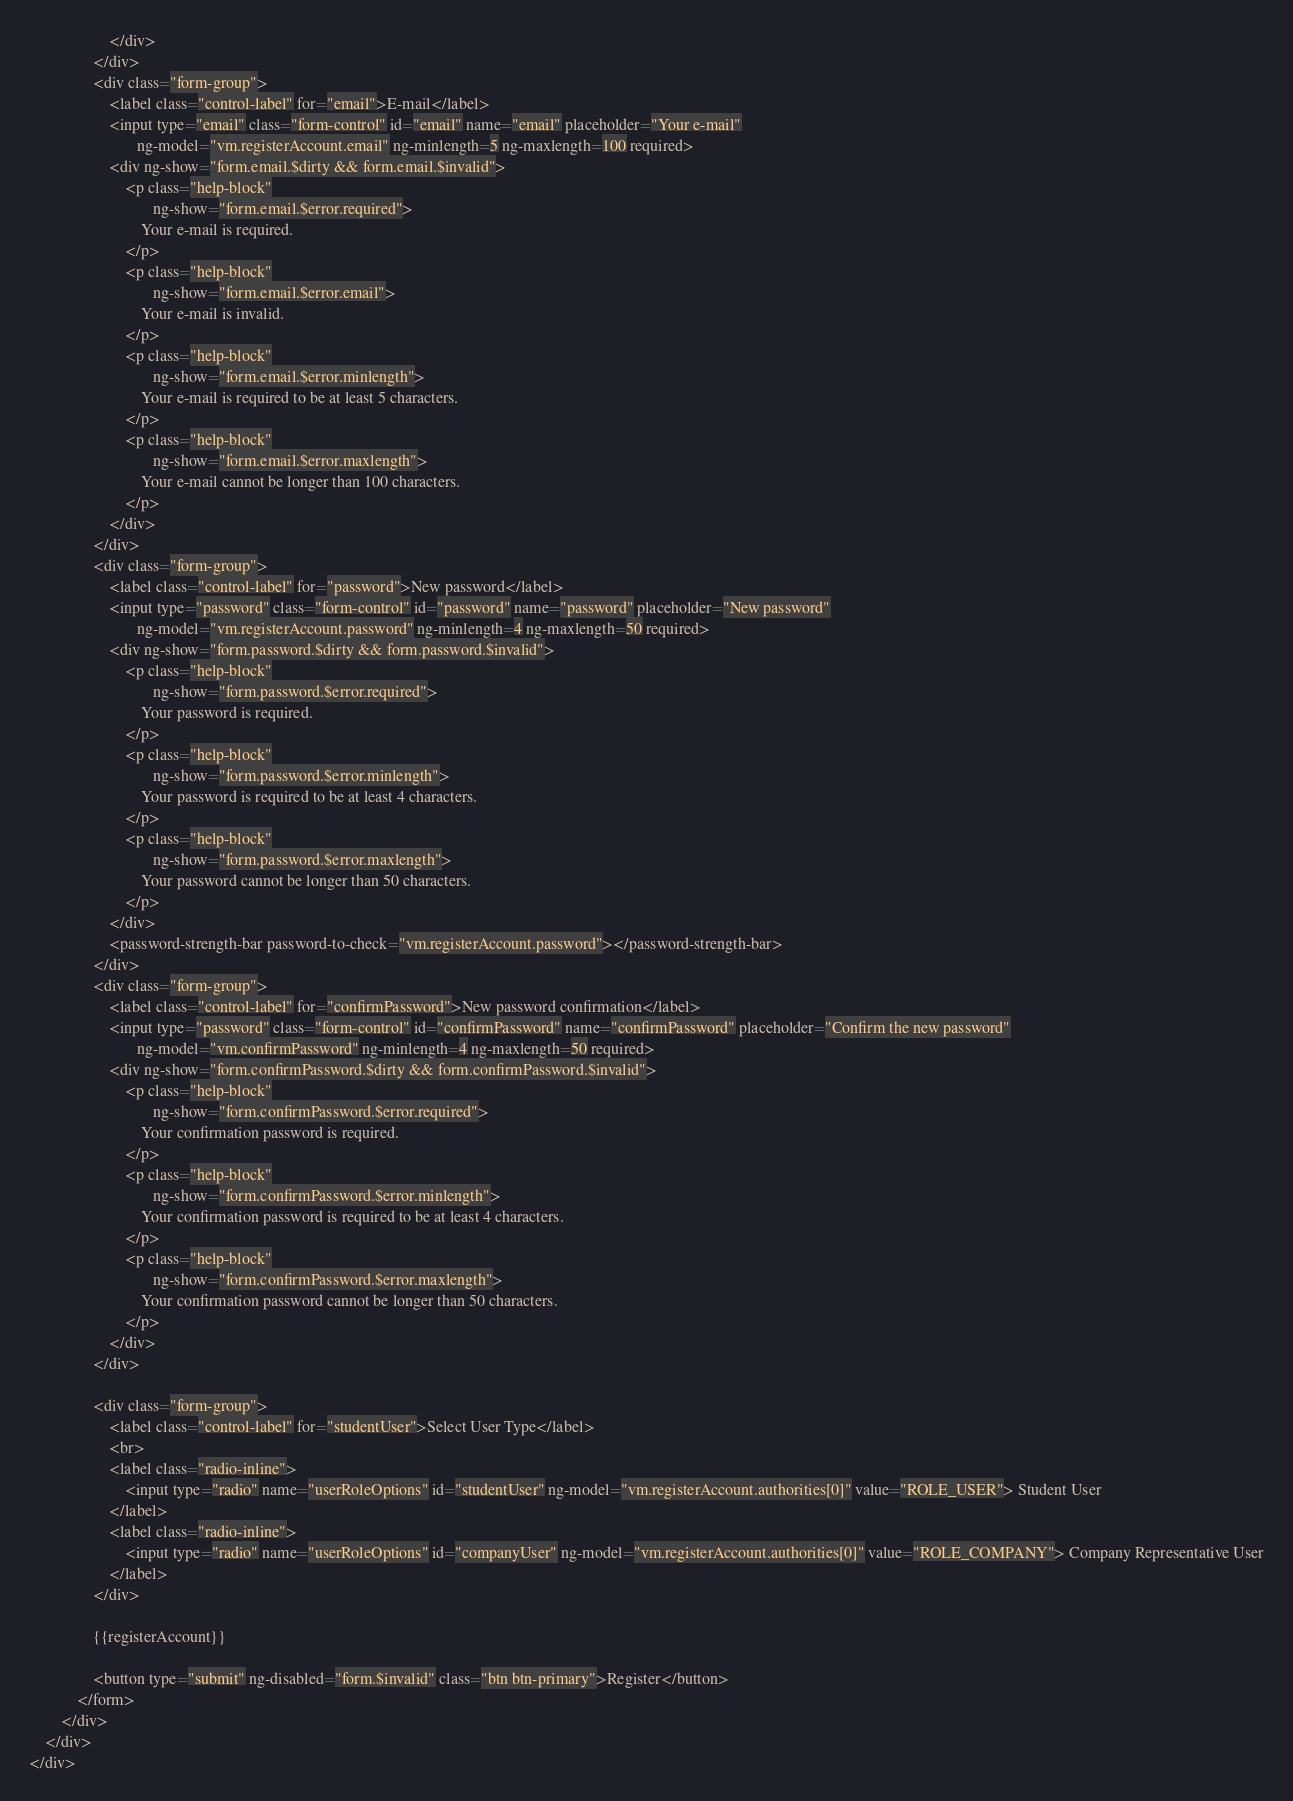<code> <loc_0><loc_0><loc_500><loc_500><_HTML_>                    </div>
                </div>
                <div class="form-group">
                    <label class="control-label" for="email">E-mail</label>
                    <input type="email" class="form-control" id="email" name="email" placeholder="Your e-mail"
                           ng-model="vm.registerAccount.email" ng-minlength=5 ng-maxlength=100 required>
                    <div ng-show="form.email.$dirty && form.email.$invalid">
                        <p class="help-block"
                               ng-show="form.email.$error.required">
                            Your e-mail is required.
                        </p>
                        <p class="help-block"
                               ng-show="form.email.$error.email">
                            Your e-mail is invalid.
                        </p>
                        <p class="help-block"
                               ng-show="form.email.$error.minlength">
                            Your e-mail is required to be at least 5 characters.
                        </p>
                        <p class="help-block"
                               ng-show="form.email.$error.maxlength">
                            Your e-mail cannot be longer than 100 characters.
                        </p>
                    </div>
                </div>
                <div class="form-group">
                    <label class="control-label" for="password">New password</label>
                    <input type="password" class="form-control" id="password" name="password" placeholder="New password"
                           ng-model="vm.registerAccount.password" ng-minlength=4 ng-maxlength=50 required>
                    <div ng-show="form.password.$dirty && form.password.$invalid">
                        <p class="help-block"
                               ng-show="form.password.$error.required">
                            Your password is required.
                        </p>
                        <p class="help-block"
                               ng-show="form.password.$error.minlength">
                            Your password is required to be at least 4 characters.
                        </p>
                        <p class="help-block"
                               ng-show="form.password.$error.maxlength">
                            Your password cannot be longer than 50 characters.
                        </p>
                    </div>
                    <password-strength-bar password-to-check="vm.registerAccount.password"></password-strength-bar>
                </div>
                <div class="form-group">
                    <label class="control-label" for="confirmPassword">New password confirmation</label>
                    <input type="password" class="form-control" id="confirmPassword" name="confirmPassword" placeholder="Confirm the new password"
                           ng-model="vm.confirmPassword" ng-minlength=4 ng-maxlength=50 required>
                    <div ng-show="form.confirmPassword.$dirty && form.confirmPassword.$invalid">
                        <p class="help-block"
                               ng-show="form.confirmPassword.$error.required">
                            Your confirmation password is required.
                        </p>
                        <p class="help-block"
                               ng-show="form.confirmPassword.$error.minlength">
                            Your confirmation password is required to be at least 4 characters.
                        </p>
                        <p class="help-block"
                               ng-show="form.confirmPassword.$error.maxlength">
                            Your confirmation password cannot be longer than 50 characters.
                        </p>
                    </div>
                </div>

                <div class="form-group">
                    <label class="control-label" for="studentUser">Select User Type</label>
                    <br>
                    <label class="radio-inline">
                        <input type="radio" name="userRoleOptions" id="studentUser" ng-model="vm.registerAccount.authorities[0]" value="ROLE_USER"> Student User
                    </label>
                    <label class="radio-inline">
                        <input type="radio" name="userRoleOptions" id="companyUser" ng-model="vm.registerAccount.authorities[0]" value="ROLE_COMPANY"> Company Representative User
                    </label>
                </div>

                {{registerAccount}}

                <button type="submit" ng-disabled="form.$invalid" class="btn btn-primary">Register</button>
            </form>
        </div>
    </div>
</div>
</code> 